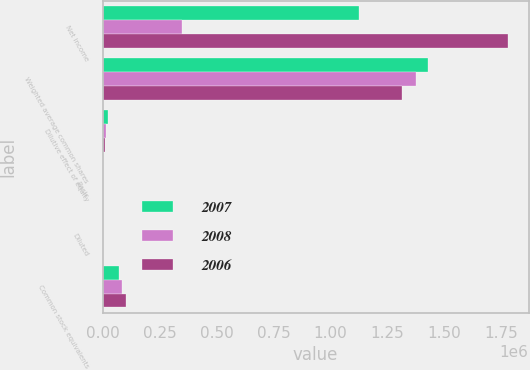<chart> <loc_0><loc_0><loc_500><loc_500><stacked_bar_chart><ecel><fcel>Net income<fcel>Weighted average common shares<fcel>Dilutive effect of equity<fcel>Basic<fcel>Diluted<fcel>Common stock equivalents<nl><fcel>2007<fcel>1.12564e+06<fcel>1.42547e+06<fcel>26221<fcel>0.8<fcel>0.79<fcel>73651<nl><fcel>2008<fcel>348251<fcel>1.37617e+06<fcel>17377<fcel>0.26<fcel>0.25<fcel>83422<nl><fcel>2006<fcel>1.77947e+06<fcel>1.31261e+06<fcel>9154<fcel>1.37<fcel>1.36<fcel>102642<nl></chart> 